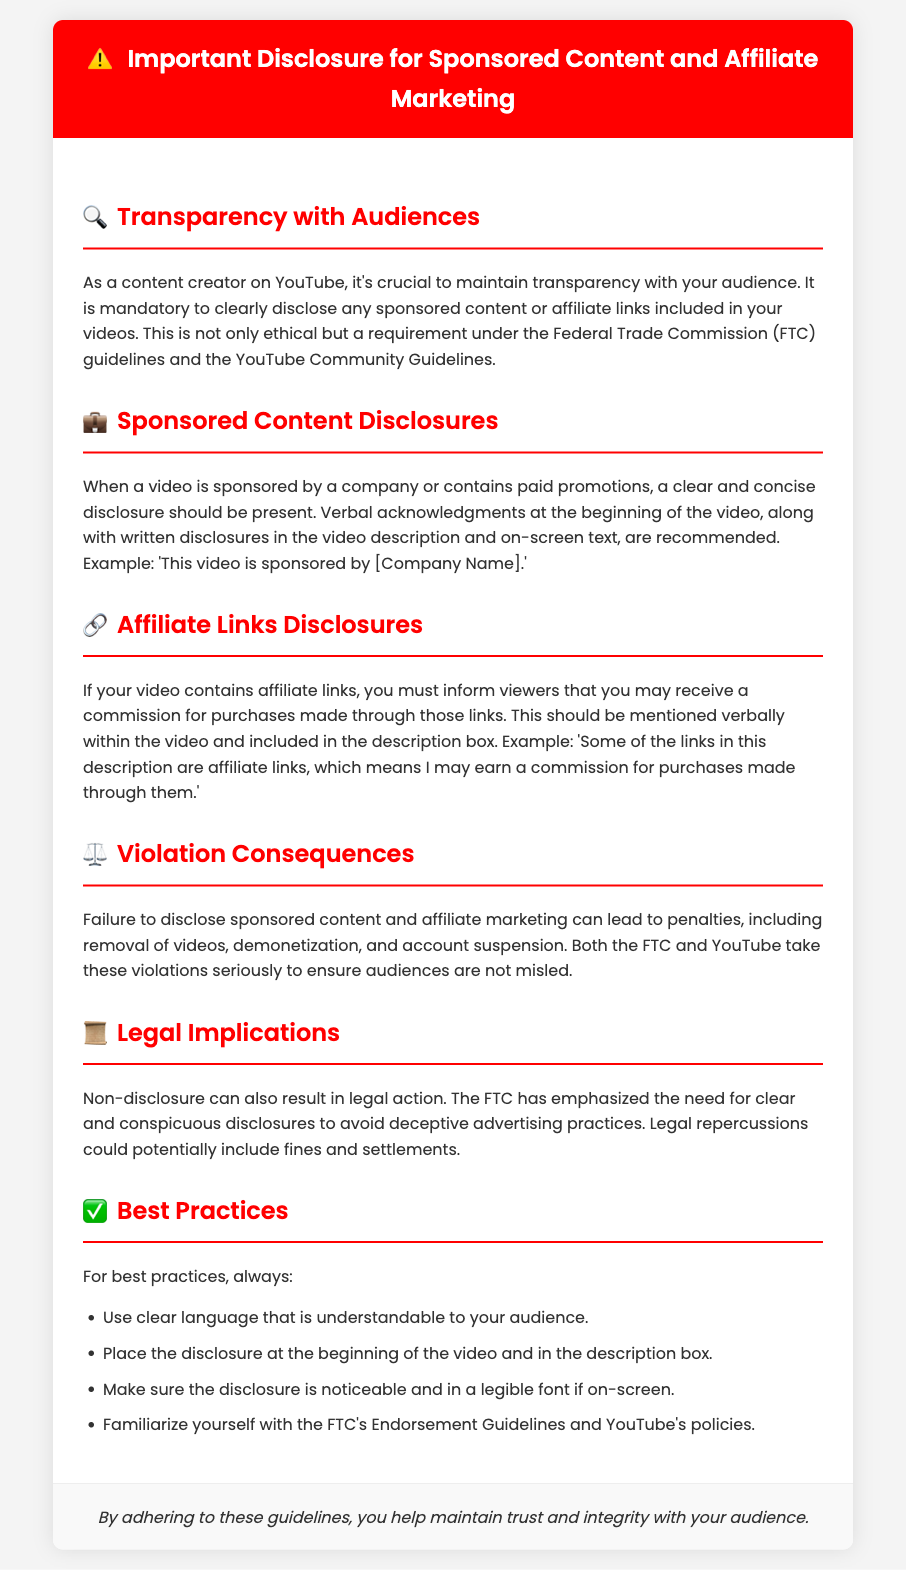What is mandatory for content creators? The document states that it's mandatory to disclose any sponsored content or affiliate links in videos.
Answer: Disclose any sponsored content or affiliate links What icon is used for Transparency with Audiences? The section on Transparency with Audiences uses the 🔍 icon in the document.
Answer: 🔍 What may happen if there is a failure to disclose? The document mentions several consequences of failure to disclose, including removal of videos and account suspension.
Answer: Removal of videos, demonetization, account suspension How should sponsored content be acknowledged? Sponsored content should be acknowledged with verbal and written disclosures in the video, as per the guidelines in the document.
Answer: Verbal and written disclosures What is a key requirement for affiliate links? The document states that viewers must be informed about potential commissions from affiliate links included in the video.
Answer: Informing viewers about commissions How should disclosures be positioned? Disclosures should be placed at the beginning of the video and also in the description box, according to best practices outlined in the document.
Answer: At the beginning and in the description box What legal authority is mentioned concerning disclosures? The document refers to the Federal Trade Commission (FTC) regarding the need for disclosures.
Answer: Federal Trade Commission (FTC) What is emphasized to avoid legal repercussions? The document emphasizes the need for clear and conspicuous disclosures to avoid deceptive advertising practices.
Answer: Clear and conspicuous disclosures 